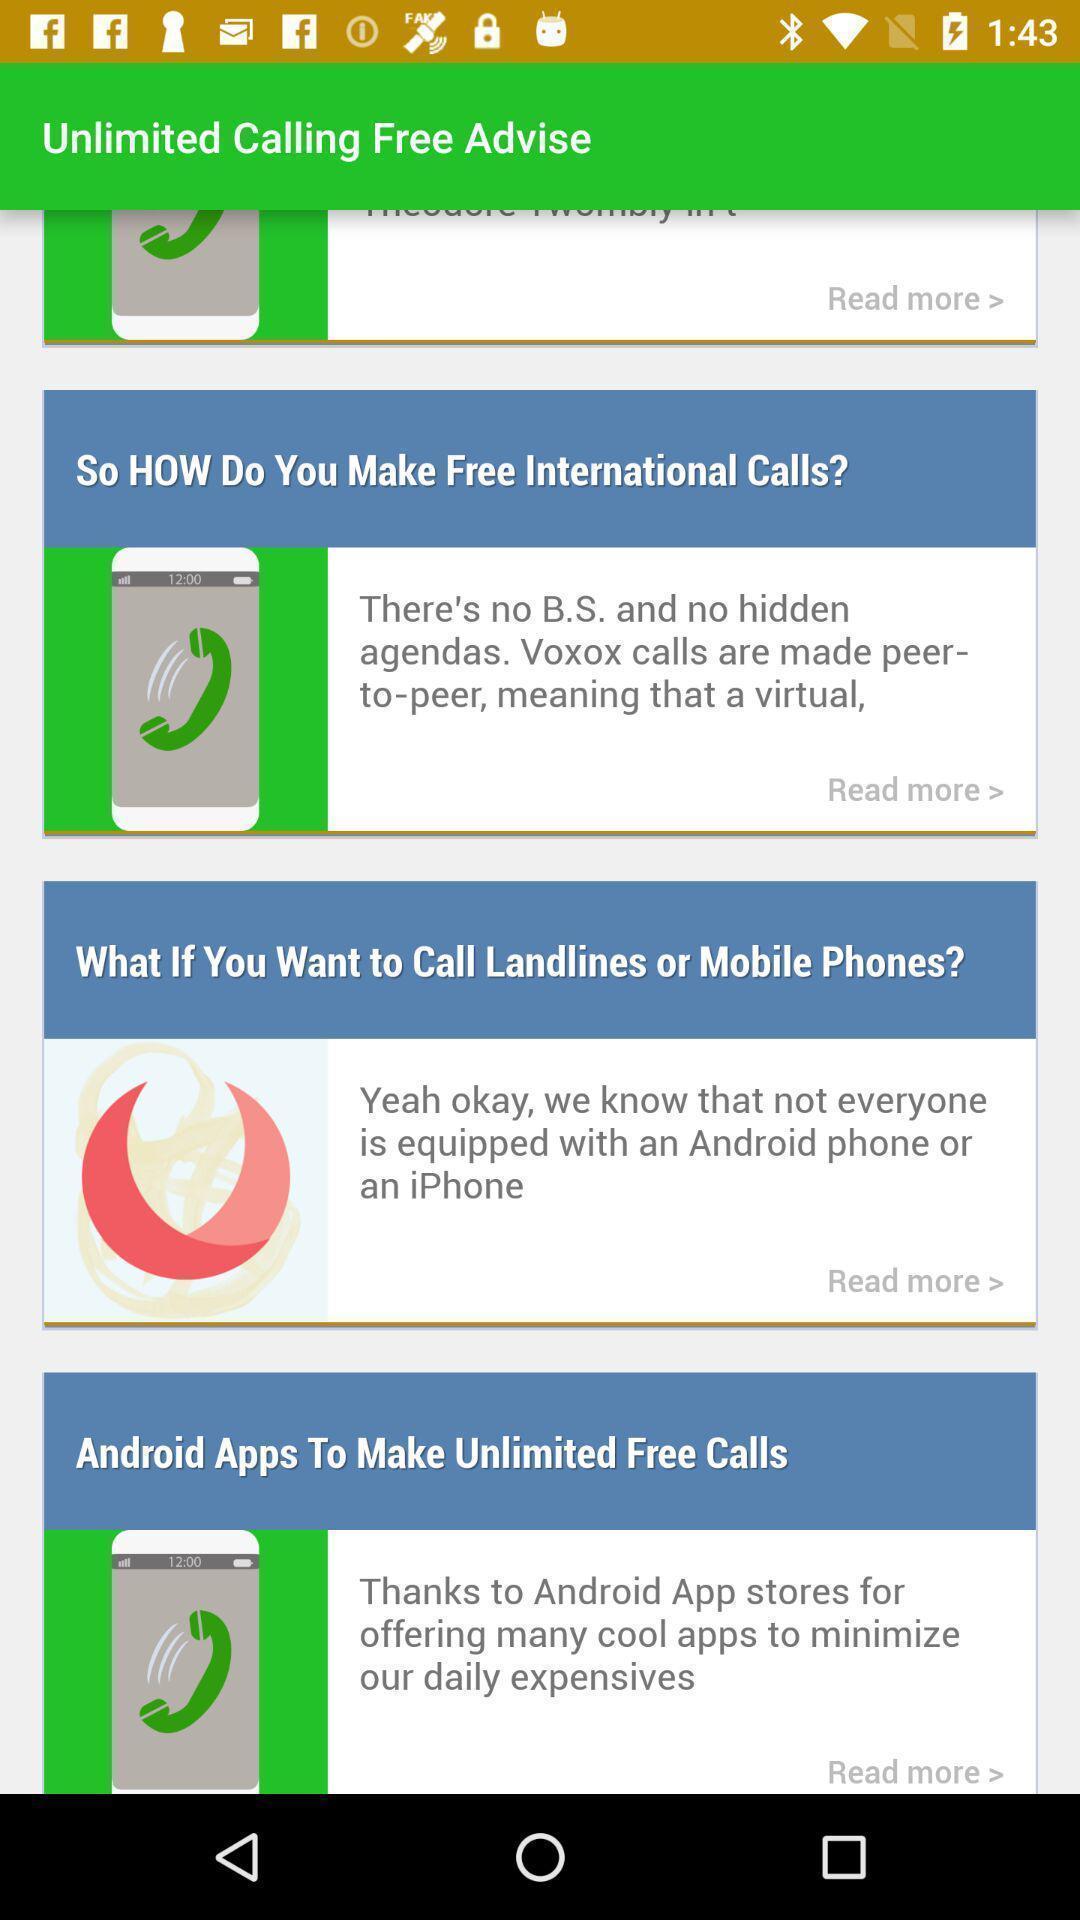Describe the content in this image. Page showing content related to an app. 